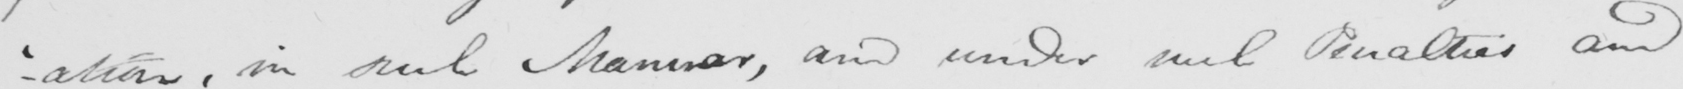What is written in this line of handwriting? - ' ation , in such Manner , and under such Penalties and 